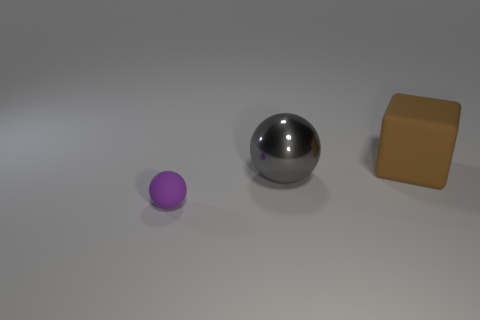Is there anything else that has the same shape as the metallic object?
Provide a succinct answer. Yes. There is a big thing on the right side of the big ball; what shape is it?
Ensure brevity in your answer.  Cube. What is the shape of the matte thing right of the ball behind the matte object that is left of the large gray thing?
Offer a very short reply. Cube. What number of objects are big cylinders or large things?
Your answer should be very brief. 2. Does the rubber object in front of the large brown rubber block have the same shape as the big thing that is on the left side of the brown cube?
Ensure brevity in your answer.  Yes. What number of objects are on the left side of the big brown rubber block and right of the small purple sphere?
Give a very brief answer. 1. What number of other things are the same size as the brown object?
Provide a short and direct response. 1. What size is the other thing that is the same shape as the big shiny thing?
Provide a succinct answer. Small. Does the metallic ball have the same size as the object behind the shiny object?
Provide a succinct answer. Yes. What color is the other big shiny object that is the same shape as the purple thing?
Provide a short and direct response. Gray. 